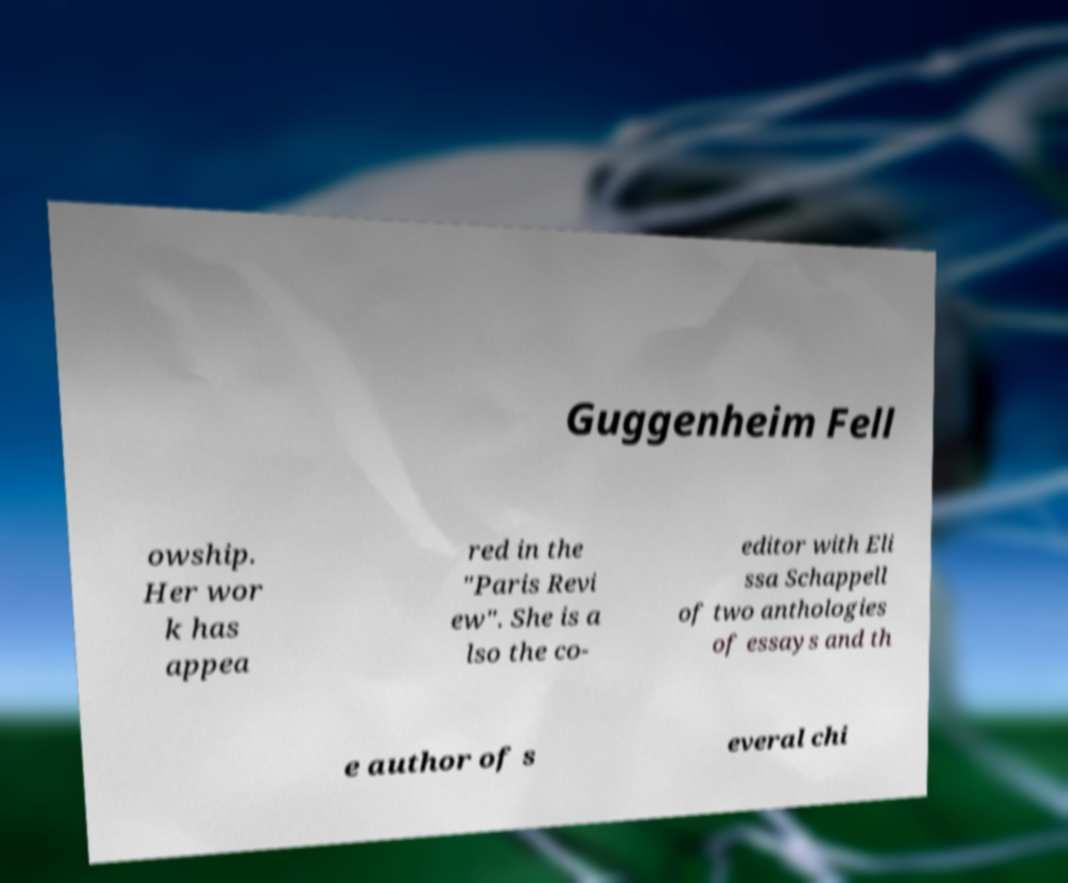Could you assist in decoding the text presented in this image and type it out clearly? Guggenheim Fell owship. Her wor k has appea red in the "Paris Revi ew". She is a lso the co- editor with Eli ssa Schappell of two anthologies of essays and th e author of s everal chi 